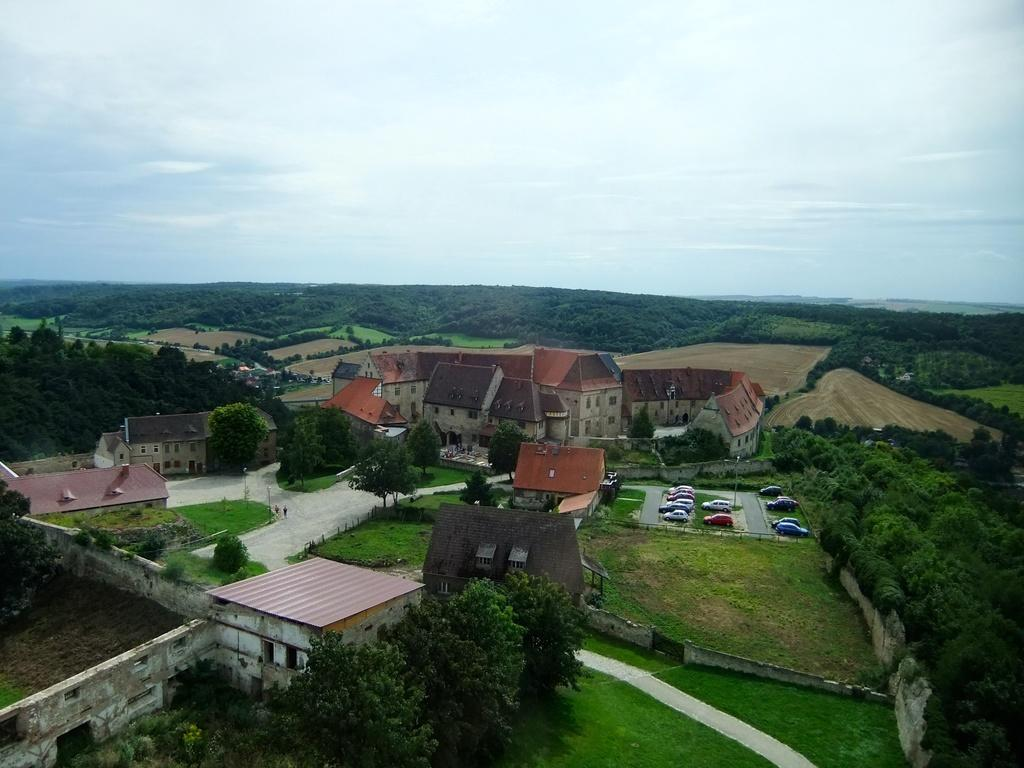What type of structures can be seen in the image? There are many buildings in the image. What natural elements are present in the image? There are trees in the image. What type of infrastructure is visible in the image? There are roads in the image. What type of boundary or enclosure can be seen in the image? There are compound walls in the image. What type of transportation is present in the image? There are vehicles in the image. What can be seen in the background of the image? The sky is visible in the background of the image. What type of apparel is the tree wearing in the image? Trees do not wear apparel; they are natural elements and do not have clothing. What book is the vehicle reading in the image? Vehicles do not read books; they are inanimate objects and do not have the ability to read. 